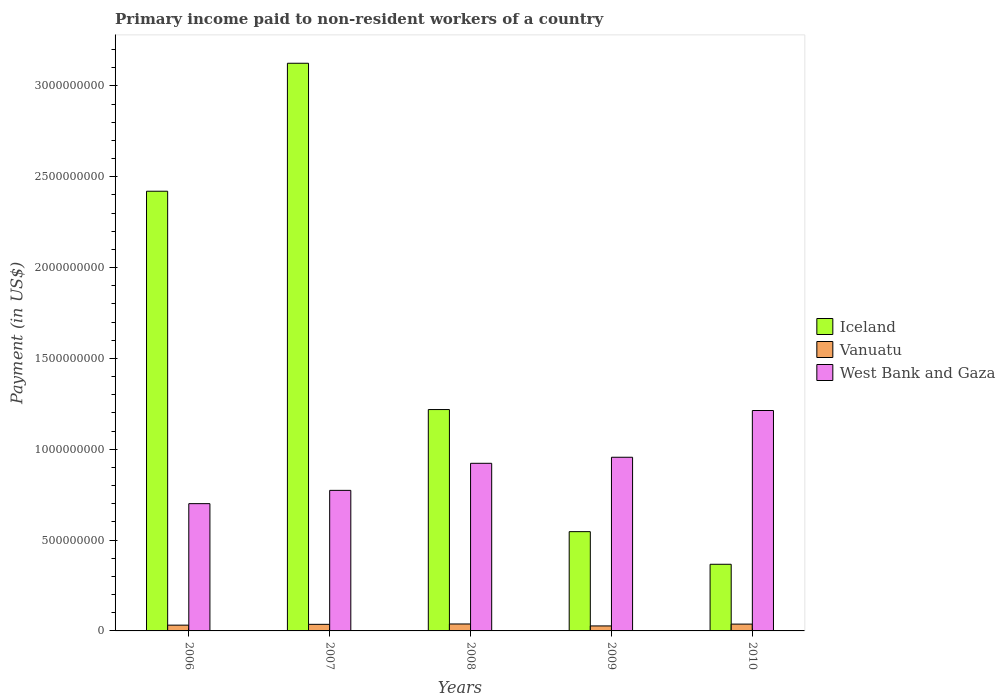How many different coloured bars are there?
Offer a very short reply. 3. How many groups of bars are there?
Provide a succinct answer. 5. How many bars are there on the 3rd tick from the left?
Provide a short and direct response. 3. How many bars are there on the 4th tick from the right?
Make the answer very short. 3. What is the label of the 5th group of bars from the left?
Give a very brief answer. 2010. In how many cases, is the number of bars for a given year not equal to the number of legend labels?
Provide a short and direct response. 0. What is the amount paid to workers in Vanuatu in 2006?
Give a very brief answer. 3.18e+07. Across all years, what is the maximum amount paid to workers in West Bank and Gaza?
Provide a short and direct response. 1.21e+09. Across all years, what is the minimum amount paid to workers in West Bank and Gaza?
Provide a succinct answer. 7.01e+08. In which year was the amount paid to workers in West Bank and Gaza minimum?
Make the answer very short. 2006. What is the total amount paid to workers in Iceland in the graph?
Provide a short and direct response. 7.68e+09. What is the difference between the amount paid to workers in Iceland in 2009 and that in 2010?
Give a very brief answer. 1.80e+08. What is the difference between the amount paid to workers in West Bank and Gaza in 2008 and the amount paid to workers in Vanuatu in 2010?
Make the answer very short. 8.85e+08. What is the average amount paid to workers in West Bank and Gaza per year?
Keep it short and to the point. 9.13e+08. In the year 2008, what is the difference between the amount paid to workers in West Bank and Gaza and amount paid to workers in Vanuatu?
Your answer should be compact. 8.84e+08. In how many years, is the amount paid to workers in Vanuatu greater than 800000000 US$?
Your answer should be compact. 0. What is the ratio of the amount paid to workers in Vanuatu in 2006 to that in 2007?
Offer a terse response. 0.88. Is the difference between the amount paid to workers in West Bank and Gaza in 2006 and 2007 greater than the difference between the amount paid to workers in Vanuatu in 2006 and 2007?
Provide a succinct answer. No. What is the difference between the highest and the second highest amount paid to workers in Iceland?
Your response must be concise. 7.04e+08. What is the difference between the highest and the lowest amount paid to workers in Iceland?
Ensure brevity in your answer.  2.76e+09. What does the 2nd bar from the left in 2009 represents?
Make the answer very short. Vanuatu. What does the 2nd bar from the right in 2008 represents?
Make the answer very short. Vanuatu. What is the difference between two consecutive major ticks on the Y-axis?
Offer a very short reply. 5.00e+08. Does the graph contain grids?
Offer a terse response. No. Where does the legend appear in the graph?
Your answer should be very brief. Center right. How many legend labels are there?
Provide a succinct answer. 3. How are the legend labels stacked?
Your answer should be compact. Vertical. What is the title of the graph?
Your answer should be very brief. Primary income paid to non-resident workers of a country. What is the label or title of the Y-axis?
Offer a very short reply. Payment (in US$). What is the Payment (in US$) in Iceland in 2006?
Give a very brief answer. 2.42e+09. What is the Payment (in US$) of Vanuatu in 2006?
Your response must be concise. 3.18e+07. What is the Payment (in US$) in West Bank and Gaza in 2006?
Your response must be concise. 7.01e+08. What is the Payment (in US$) in Iceland in 2007?
Ensure brevity in your answer.  3.12e+09. What is the Payment (in US$) in Vanuatu in 2007?
Your answer should be very brief. 3.63e+07. What is the Payment (in US$) in West Bank and Gaza in 2007?
Offer a very short reply. 7.74e+08. What is the Payment (in US$) in Iceland in 2008?
Keep it short and to the point. 1.22e+09. What is the Payment (in US$) in Vanuatu in 2008?
Make the answer very short. 3.82e+07. What is the Payment (in US$) of West Bank and Gaza in 2008?
Give a very brief answer. 9.23e+08. What is the Payment (in US$) of Iceland in 2009?
Your response must be concise. 5.46e+08. What is the Payment (in US$) of Vanuatu in 2009?
Your response must be concise. 2.74e+07. What is the Payment (in US$) in West Bank and Gaza in 2009?
Your answer should be compact. 9.56e+08. What is the Payment (in US$) of Iceland in 2010?
Offer a terse response. 3.67e+08. What is the Payment (in US$) in Vanuatu in 2010?
Ensure brevity in your answer.  3.75e+07. What is the Payment (in US$) in West Bank and Gaza in 2010?
Your answer should be compact. 1.21e+09. Across all years, what is the maximum Payment (in US$) of Iceland?
Your answer should be compact. 3.12e+09. Across all years, what is the maximum Payment (in US$) of Vanuatu?
Offer a very short reply. 3.82e+07. Across all years, what is the maximum Payment (in US$) of West Bank and Gaza?
Your answer should be compact. 1.21e+09. Across all years, what is the minimum Payment (in US$) in Iceland?
Your response must be concise. 3.67e+08. Across all years, what is the minimum Payment (in US$) of Vanuatu?
Your response must be concise. 2.74e+07. Across all years, what is the minimum Payment (in US$) of West Bank and Gaza?
Provide a succinct answer. 7.01e+08. What is the total Payment (in US$) in Iceland in the graph?
Your response must be concise. 7.68e+09. What is the total Payment (in US$) of Vanuatu in the graph?
Provide a succinct answer. 1.71e+08. What is the total Payment (in US$) of West Bank and Gaza in the graph?
Give a very brief answer. 4.57e+09. What is the difference between the Payment (in US$) in Iceland in 2006 and that in 2007?
Provide a succinct answer. -7.04e+08. What is the difference between the Payment (in US$) of Vanuatu in 2006 and that in 2007?
Your answer should be compact. -4.45e+06. What is the difference between the Payment (in US$) of West Bank and Gaza in 2006 and that in 2007?
Keep it short and to the point. -7.31e+07. What is the difference between the Payment (in US$) in Iceland in 2006 and that in 2008?
Offer a terse response. 1.20e+09. What is the difference between the Payment (in US$) in Vanuatu in 2006 and that in 2008?
Keep it short and to the point. -6.42e+06. What is the difference between the Payment (in US$) of West Bank and Gaza in 2006 and that in 2008?
Offer a very short reply. -2.22e+08. What is the difference between the Payment (in US$) of Iceland in 2006 and that in 2009?
Give a very brief answer. 1.87e+09. What is the difference between the Payment (in US$) of Vanuatu in 2006 and that in 2009?
Make the answer very short. 4.37e+06. What is the difference between the Payment (in US$) of West Bank and Gaza in 2006 and that in 2009?
Offer a terse response. -2.55e+08. What is the difference between the Payment (in US$) in Iceland in 2006 and that in 2010?
Make the answer very short. 2.05e+09. What is the difference between the Payment (in US$) of Vanuatu in 2006 and that in 2010?
Make the answer very short. -5.68e+06. What is the difference between the Payment (in US$) in West Bank and Gaza in 2006 and that in 2010?
Offer a terse response. -5.13e+08. What is the difference between the Payment (in US$) of Iceland in 2007 and that in 2008?
Provide a short and direct response. 1.91e+09. What is the difference between the Payment (in US$) of Vanuatu in 2007 and that in 2008?
Provide a succinct answer. -1.97e+06. What is the difference between the Payment (in US$) of West Bank and Gaza in 2007 and that in 2008?
Provide a short and direct response. -1.49e+08. What is the difference between the Payment (in US$) in Iceland in 2007 and that in 2009?
Give a very brief answer. 2.58e+09. What is the difference between the Payment (in US$) of Vanuatu in 2007 and that in 2009?
Make the answer very short. 8.82e+06. What is the difference between the Payment (in US$) in West Bank and Gaza in 2007 and that in 2009?
Provide a succinct answer. -1.82e+08. What is the difference between the Payment (in US$) of Iceland in 2007 and that in 2010?
Your answer should be compact. 2.76e+09. What is the difference between the Payment (in US$) of Vanuatu in 2007 and that in 2010?
Make the answer very short. -1.23e+06. What is the difference between the Payment (in US$) in West Bank and Gaza in 2007 and that in 2010?
Offer a terse response. -4.40e+08. What is the difference between the Payment (in US$) of Iceland in 2008 and that in 2009?
Your answer should be compact. 6.72e+08. What is the difference between the Payment (in US$) in Vanuatu in 2008 and that in 2009?
Make the answer very short. 1.08e+07. What is the difference between the Payment (in US$) of West Bank and Gaza in 2008 and that in 2009?
Ensure brevity in your answer.  -3.33e+07. What is the difference between the Payment (in US$) in Iceland in 2008 and that in 2010?
Ensure brevity in your answer.  8.52e+08. What is the difference between the Payment (in US$) of Vanuatu in 2008 and that in 2010?
Provide a succinct answer. 7.41e+05. What is the difference between the Payment (in US$) in West Bank and Gaza in 2008 and that in 2010?
Your answer should be very brief. -2.91e+08. What is the difference between the Payment (in US$) of Iceland in 2009 and that in 2010?
Make the answer very short. 1.80e+08. What is the difference between the Payment (in US$) of Vanuatu in 2009 and that in 2010?
Keep it short and to the point. -1.01e+07. What is the difference between the Payment (in US$) of West Bank and Gaza in 2009 and that in 2010?
Your answer should be very brief. -2.57e+08. What is the difference between the Payment (in US$) of Iceland in 2006 and the Payment (in US$) of Vanuatu in 2007?
Provide a succinct answer. 2.38e+09. What is the difference between the Payment (in US$) of Iceland in 2006 and the Payment (in US$) of West Bank and Gaza in 2007?
Provide a short and direct response. 1.65e+09. What is the difference between the Payment (in US$) of Vanuatu in 2006 and the Payment (in US$) of West Bank and Gaza in 2007?
Keep it short and to the point. -7.42e+08. What is the difference between the Payment (in US$) in Iceland in 2006 and the Payment (in US$) in Vanuatu in 2008?
Offer a terse response. 2.38e+09. What is the difference between the Payment (in US$) in Iceland in 2006 and the Payment (in US$) in West Bank and Gaza in 2008?
Ensure brevity in your answer.  1.50e+09. What is the difference between the Payment (in US$) of Vanuatu in 2006 and the Payment (in US$) of West Bank and Gaza in 2008?
Provide a succinct answer. -8.91e+08. What is the difference between the Payment (in US$) in Iceland in 2006 and the Payment (in US$) in Vanuatu in 2009?
Provide a short and direct response. 2.39e+09. What is the difference between the Payment (in US$) in Iceland in 2006 and the Payment (in US$) in West Bank and Gaza in 2009?
Offer a terse response. 1.46e+09. What is the difference between the Payment (in US$) in Vanuatu in 2006 and the Payment (in US$) in West Bank and Gaza in 2009?
Your response must be concise. -9.24e+08. What is the difference between the Payment (in US$) of Iceland in 2006 and the Payment (in US$) of Vanuatu in 2010?
Keep it short and to the point. 2.38e+09. What is the difference between the Payment (in US$) in Iceland in 2006 and the Payment (in US$) in West Bank and Gaza in 2010?
Offer a terse response. 1.21e+09. What is the difference between the Payment (in US$) in Vanuatu in 2006 and the Payment (in US$) in West Bank and Gaza in 2010?
Offer a very short reply. -1.18e+09. What is the difference between the Payment (in US$) in Iceland in 2007 and the Payment (in US$) in Vanuatu in 2008?
Your answer should be very brief. 3.09e+09. What is the difference between the Payment (in US$) in Iceland in 2007 and the Payment (in US$) in West Bank and Gaza in 2008?
Offer a terse response. 2.20e+09. What is the difference between the Payment (in US$) in Vanuatu in 2007 and the Payment (in US$) in West Bank and Gaza in 2008?
Provide a short and direct response. -8.86e+08. What is the difference between the Payment (in US$) in Iceland in 2007 and the Payment (in US$) in Vanuatu in 2009?
Offer a very short reply. 3.10e+09. What is the difference between the Payment (in US$) in Iceland in 2007 and the Payment (in US$) in West Bank and Gaza in 2009?
Give a very brief answer. 2.17e+09. What is the difference between the Payment (in US$) of Vanuatu in 2007 and the Payment (in US$) of West Bank and Gaza in 2009?
Your answer should be compact. -9.20e+08. What is the difference between the Payment (in US$) of Iceland in 2007 and the Payment (in US$) of Vanuatu in 2010?
Offer a very short reply. 3.09e+09. What is the difference between the Payment (in US$) in Iceland in 2007 and the Payment (in US$) in West Bank and Gaza in 2010?
Provide a succinct answer. 1.91e+09. What is the difference between the Payment (in US$) in Vanuatu in 2007 and the Payment (in US$) in West Bank and Gaza in 2010?
Your answer should be compact. -1.18e+09. What is the difference between the Payment (in US$) of Iceland in 2008 and the Payment (in US$) of Vanuatu in 2009?
Your answer should be very brief. 1.19e+09. What is the difference between the Payment (in US$) in Iceland in 2008 and the Payment (in US$) in West Bank and Gaza in 2009?
Make the answer very short. 2.63e+08. What is the difference between the Payment (in US$) of Vanuatu in 2008 and the Payment (in US$) of West Bank and Gaza in 2009?
Make the answer very short. -9.18e+08. What is the difference between the Payment (in US$) of Iceland in 2008 and the Payment (in US$) of Vanuatu in 2010?
Give a very brief answer. 1.18e+09. What is the difference between the Payment (in US$) of Iceland in 2008 and the Payment (in US$) of West Bank and Gaza in 2010?
Keep it short and to the point. 5.23e+06. What is the difference between the Payment (in US$) of Vanuatu in 2008 and the Payment (in US$) of West Bank and Gaza in 2010?
Your response must be concise. -1.17e+09. What is the difference between the Payment (in US$) in Iceland in 2009 and the Payment (in US$) in Vanuatu in 2010?
Your answer should be very brief. 5.09e+08. What is the difference between the Payment (in US$) in Iceland in 2009 and the Payment (in US$) in West Bank and Gaza in 2010?
Give a very brief answer. -6.67e+08. What is the difference between the Payment (in US$) of Vanuatu in 2009 and the Payment (in US$) of West Bank and Gaza in 2010?
Give a very brief answer. -1.19e+09. What is the average Payment (in US$) in Iceland per year?
Offer a terse response. 1.54e+09. What is the average Payment (in US$) of Vanuatu per year?
Keep it short and to the point. 3.43e+07. What is the average Payment (in US$) of West Bank and Gaza per year?
Your answer should be very brief. 9.13e+08. In the year 2006, what is the difference between the Payment (in US$) in Iceland and Payment (in US$) in Vanuatu?
Make the answer very short. 2.39e+09. In the year 2006, what is the difference between the Payment (in US$) of Iceland and Payment (in US$) of West Bank and Gaza?
Make the answer very short. 1.72e+09. In the year 2006, what is the difference between the Payment (in US$) of Vanuatu and Payment (in US$) of West Bank and Gaza?
Your response must be concise. -6.69e+08. In the year 2007, what is the difference between the Payment (in US$) of Iceland and Payment (in US$) of Vanuatu?
Your response must be concise. 3.09e+09. In the year 2007, what is the difference between the Payment (in US$) of Iceland and Payment (in US$) of West Bank and Gaza?
Offer a very short reply. 2.35e+09. In the year 2007, what is the difference between the Payment (in US$) of Vanuatu and Payment (in US$) of West Bank and Gaza?
Your response must be concise. -7.37e+08. In the year 2008, what is the difference between the Payment (in US$) of Iceland and Payment (in US$) of Vanuatu?
Provide a short and direct response. 1.18e+09. In the year 2008, what is the difference between the Payment (in US$) in Iceland and Payment (in US$) in West Bank and Gaza?
Offer a terse response. 2.96e+08. In the year 2008, what is the difference between the Payment (in US$) of Vanuatu and Payment (in US$) of West Bank and Gaza?
Offer a very short reply. -8.84e+08. In the year 2009, what is the difference between the Payment (in US$) of Iceland and Payment (in US$) of Vanuatu?
Provide a succinct answer. 5.19e+08. In the year 2009, what is the difference between the Payment (in US$) in Iceland and Payment (in US$) in West Bank and Gaza?
Offer a very short reply. -4.09e+08. In the year 2009, what is the difference between the Payment (in US$) of Vanuatu and Payment (in US$) of West Bank and Gaza?
Give a very brief answer. -9.28e+08. In the year 2010, what is the difference between the Payment (in US$) of Iceland and Payment (in US$) of Vanuatu?
Give a very brief answer. 3.29e+08. In the year 2010, what is the difference between the Payment (in US$) in Iceland and Payment (in US$) in West Bank and Gaza?
Give a very brief answer. -8.46e+08. In the year 2010, what is the difference between the Payment (in US$) of Vanuatu and Payment (in US$) of West Bank and Gaza?
Your answer should be compact. -1.18e+09. What is the ratio of the Payment (in US$) in Iceland in 2006 to that in 2007?
Make the answer very short. 0.77. What is the ratio of the Payment (in US$) of Vanuatu in 2006 to that in 2007?
Offer a terse response. 0.88. What is the ratio of the Payment (in US$) in West Bank and Gaza in 2006 to that in 2007?
Your answer should be very brief. 0.91. What is the ratio of the Payment (in US$) of Iceland in 2006 to that in 2008?
Your answer should be compact. 1.99. What is the ratio of the Payment (in US$) of Vanuatu in 2006 to that in 2008?
Your response must be concise. 0.83. What is the ratio of the Payment (in US$) of West Bank and Gaza in 2006 to that in 2008?
Provide a succinct answer. 0.76. What is the ratio of the Payment (in US$) of Iceland in 2006 to that in 2009?
Make the answer very short. 4.43. What is the ratio of the Payment (in US$) in Vanuatu in 2006 to that in 2009?
Your answer should be very brief. 1.16. What is the ratio of the Payment (in US$) of West Bank and Gaza in 2006 to that in 2009?
Offer a terse response. 0.73. What is the ratio of the Payment (in US$) of Iceland in 2006 to that in 2010?
Offer a very short reply. 6.6. What is the ratio of the Payment (in US$) in Vanuatu in 2006 to that in 2010?
Keep it short and to the point. 0.85. What is the ratio of the Payment (in US$) in West Bank and Gaza in 2006 to that in 2010?
Your answer should be very brief. 0.58. What is the ratio of the Payment (in US$) of Iceland in 2007 to that in 2008?
Your answer should be compact. 2.56. What is the ratio of the Payment (in US$) of Vanuatu in 2007 to that in 2008?
Offer a terse response. 0.95. What is the ratio of the Payment (in US$) in West Bank and Gaza in 2007 to that in 2008?
Give a very brief answer. 0.84. What is the ratio of the Payment (in US$) in Iceland in 2007 to that in 2009?
Your response must be concise. 5.72. What is the ratio of the Payment (in US$) of Vanuatu in 2007 to that in 2009?
Your answer should be very brief. 1.32. What is the ratio of the Payment (in US$) of West Bank and Gaza in 2007 to that in 2009?
Your answer should be very brief. 0.81. What is the ratio of the Payment (in US$) in Iceland in 2007 to that in 2010?
Your response must be concise. 8.52. What is the ratio of the Payment (in US$) in Vanuatu in 2007 to that in 2010?
Your response must be concise. 0.97. What is the ratio of the Payment (in US$) of West Bank and Gaza in 2007 to that in 2010?
Provide a succinct answer. 0.64. What is the ratio of the Payment (in US$) of Iceland in 2008 to that in 2009?
Give a very brief answer. 2.23. What is the ratio of the Payment (in US$) in Vanuatu in 2008 to that in 2009?
Offer a very short reply. 1.39. What is the ratio of the Payment (in US$) in West Bank and Gaza in 2008 to that in 2009?
Provide a succinct answer. 0.97. What is the ratio of the Payment (in US$) in Iceland in 2008 to that in 2010?
Offer a very short reply. 3.32. What is the ratio of the Payment (in US$) of Vanuatu in 2008 to that in 2010?
Offer a very short reply. 1.02. What is the ratio of the Payment (in US$) in West Bank and Gaza in 2008 to that in 2010?
Ensure brevity in your answer.  0.76. What is the ratio of the Payment (in US$) of Iceland in 2009 to that in 2010?
Your response must be concise. 1.49. What is the ratio of the Payment (in US$) in Vanuatu in 2009 to that in 2010?
Provide a short and direct response. 0.73. What is the ratio of the Payment (in US$) of West Bank and Gaza in 2009 to that in 2010?
Offer a terse response. 0.79. What is the difference between the highest and the second highest Payment (in US$) of Iceland?
Provide a succinct answer. 7.04e+08. What is the difference between the highest and the second highest Payment (in US$) in Vanuatu?
Make the answer very short. 7.41e+05. What is the difference between the highest and the second highest Payment (in US$) in West Bank and Gaza?
Provide a succinct answer. 2.57e+08. What is the difference between the highest and the lowest Payment (in US$) of Iceland?
Ensure brevity in your answer.  2.76e+09. What is the difference between the highest and the lowest Payment (in US$) of Vanuatu?
Provide a succinct answer. 1.08e+07. What is the difference between the highest and the lowest Payment (in US$) of West Bank and Gaza?
Ensure brevity in your answer.  5.13e+08. 